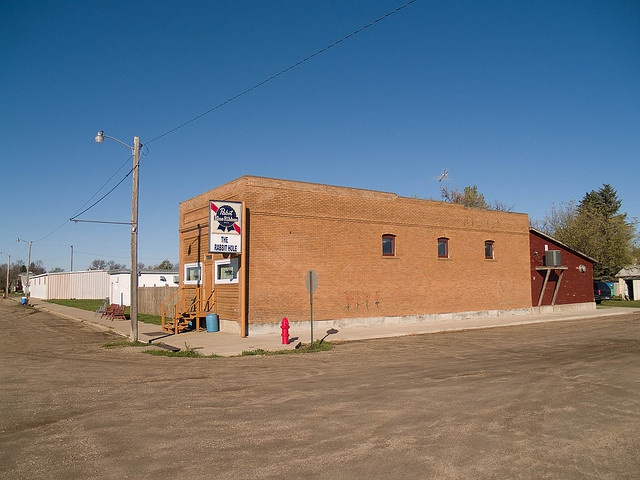Describe the objects in this image and their specific colors. I can see car in darkblue, black, maroon, gray, and navy tones, stop sign in darkblue, gray, darkgray, and tan tones, fire hydrant in darkblue, red, brown, and salmon tones, bench in darkblue, brown, and maroon tones, and chair in darkblue, brown, and maroon tones in this image. 